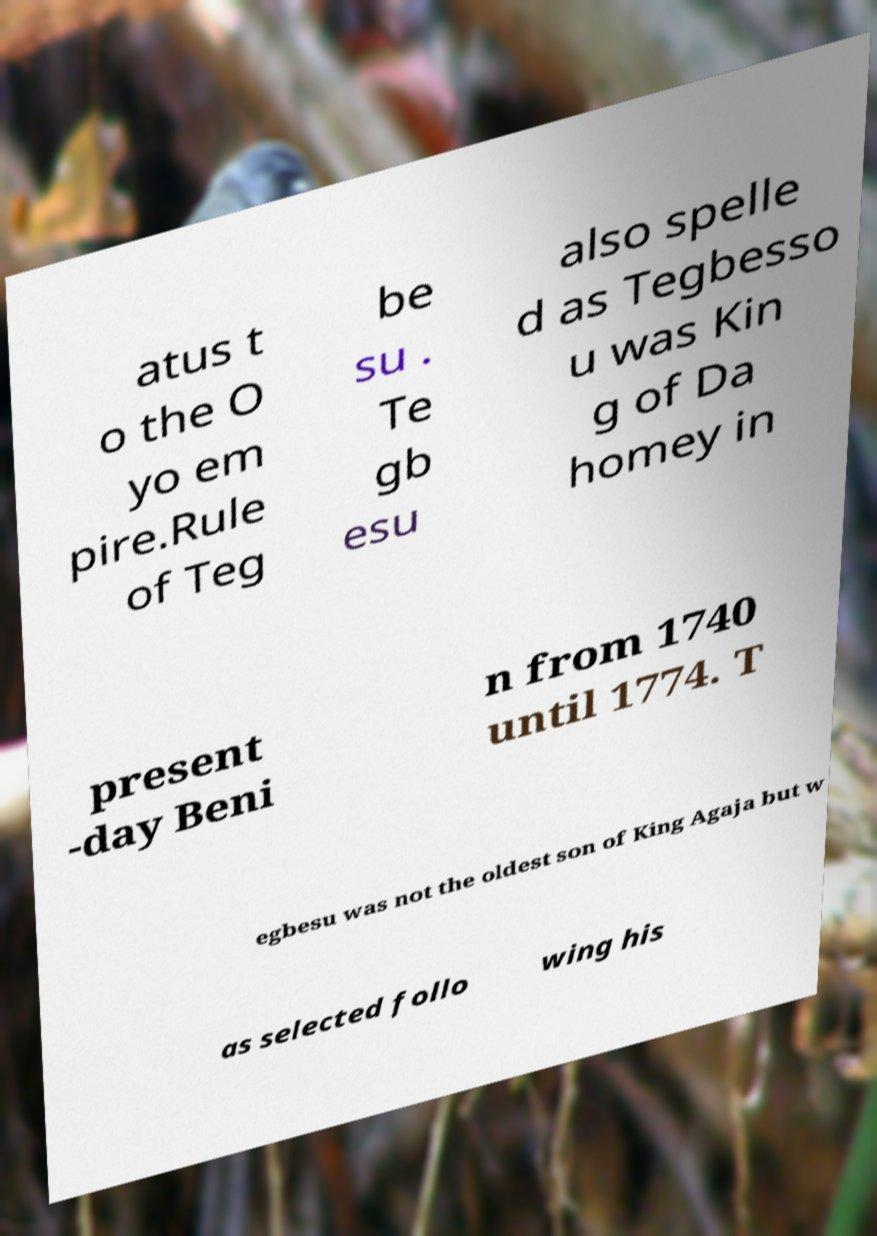I need the written content from this picture converted into text. Can you do that? atus t o the O yo em pire.Rule of Teg be su . Te gb esu also spelle d as Tegbesso u was Kin g of Da homey in present -day Beni n from 1740 until 1774. T egbesu was not the oldest son of King Agaja but w as selected follo wing his 